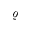Convert formula to latex. <formula><loc_0><loc_0><loc_500><loc_500>\varrho</formula> 